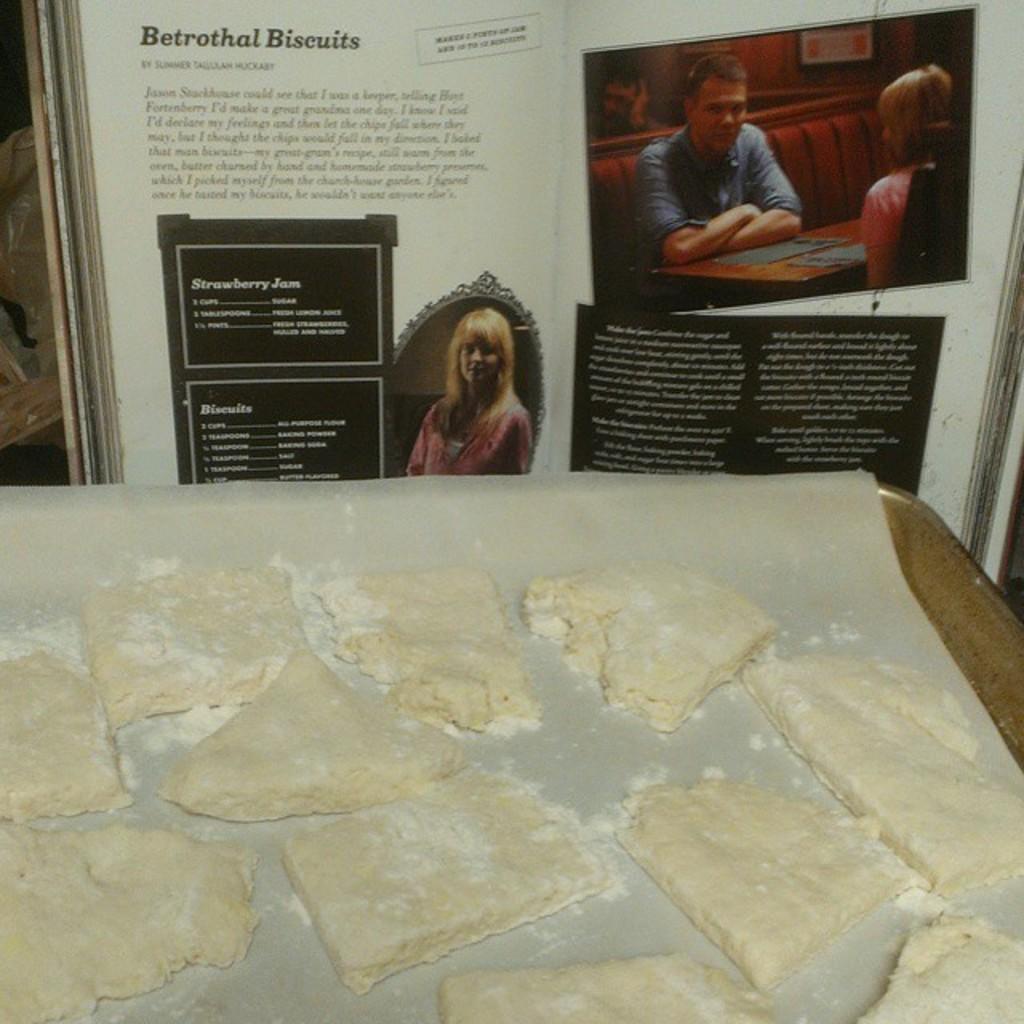In one or two sentences, can you explain what this image depicts? In this picture I can see a food item on the paper, on the tray, and in the background there is a book. 